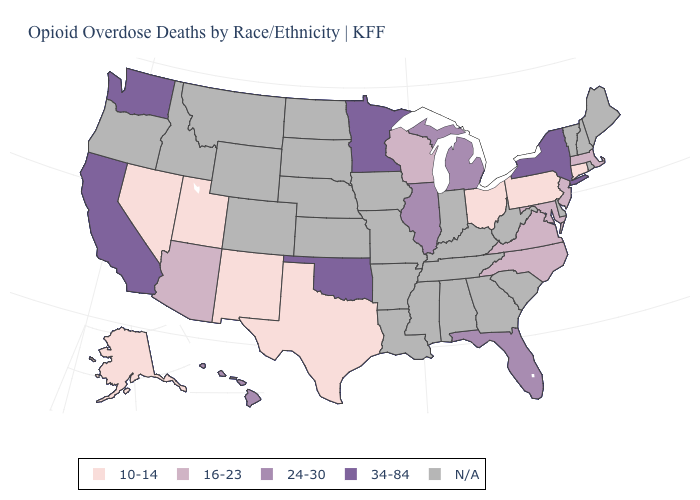Does Ohio have the lowest value in the MidWest?
Answer briefly. Yes. What is the value of Wisconsin?
Concise answer only. 16-23. Name the states that have a value in the range 34-84?
Concise answer only. California, Minnesota, New York, Oklahoma, Washington. What is the value of Florida?
Concise answer only. 24-30. Among the states that border Colorado , which have the highest value?
Keep it brief. Oklahoma. Does Washington have the highest value in the USA?
Concise answer only. Yes. Is the legend a continuous bar?
Quick response, please. No. What is the value of Florida?
Concise answer only. 24-30. Is the legend a continuous bar?
Short answer required. No. Name the states that have a value in the range 16-23?
Keep it brief. Arizona, Maryland, Massachusetts, New Jersey, North Carolina, Virginia, Wisconsin. Among the states that border Wisconsin , which have the highest value?
Give a very brief answer. Minnesota. Does the first symbol in the legend represent the smallest category?
Quick response, please. Yes. Name the states that have a value in the range 10-14?
Answer briefly. Alaska, Connecticut, Nevada, New Mexico, Ohio, Pennsylvania, Texas, Utah. Name the states that have a value in the range 24-30?
Concise answer only. Florida, Hawaii, Illinois, Michigan. Does Illinois have the highest value in the USA?
Be succinct. No. 